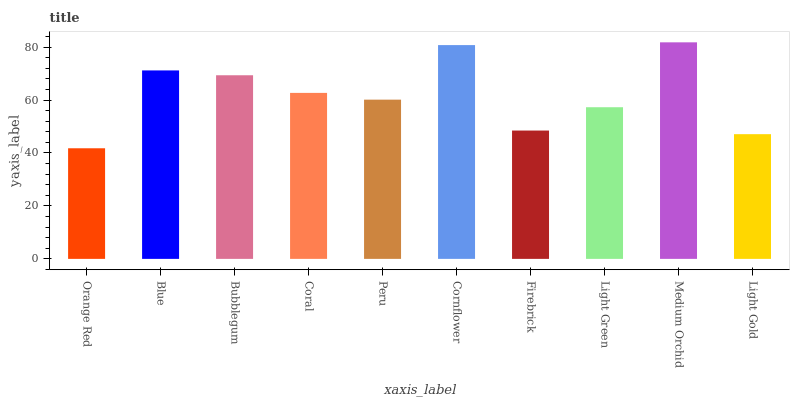Is Orange Red the minimum?
Answer yes or no. Yes. Is Medium Orchid the maximum?
Answer yes or no. Yes. Is Blue the minimum?
Answer yes or no. No. Is Blue the maximum?
Answer yes or no. No. Is Blue greater than Orange Red?
Answer yes or no. Yes. Is Orange Red less than Blue?
Answer yes or no. Yes. Is Orange Red greater than Blue?
Answer yes or no. No. Is Blue less than Orange Red?
Answer yes or no. No. Is Coral the high median?
Answer yes or no. Yes. Is Peru the low median?
Answer yes or no. Yes. Is Medium Orchid the high median?
Answer yes or no. No. Is Light Green the low median?
Answer yes or no. No. 